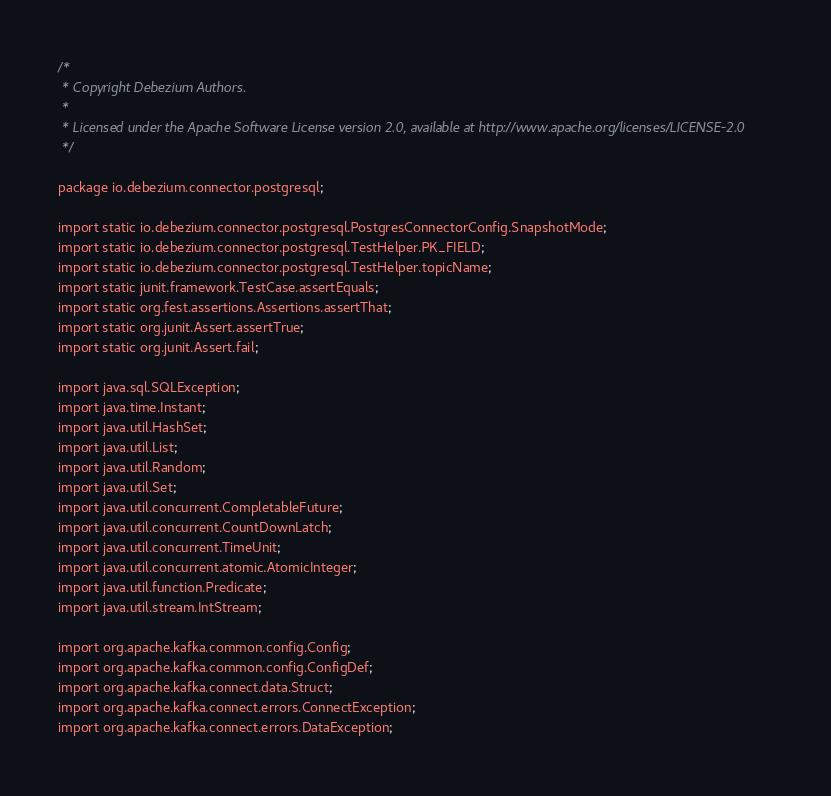<code> <loc_0><loc_0><loc_500><loc_500><_Java_>/*
 * Copyright Debezium Authors.
 *
 * Licensed under the Apache Software License version 2.0, available at http://www.apache.org/licenses/LICENSE-2.0
 */

package io.debezium.connector.postgresql;

import static io.debezium.connector.postgresql.PostgresConnectorConfig.SnapshotMode;
import static io.debezium.connector.postgresql.TestHelper.PK_FIELD;
import static io.debezium.connector.postgresql.TestHelper.topicName;
import static junit.framework.TestCase.assertEquals;
import static org.fest.assertions.Assertions.assertThat;
import static org.junit.Assert.assertTrue;
import static org.junit.Assert.fail;

import java.sql.SQLException;
import java.time.Instant;
import java.util.HashSet;
import java.util.List;
import java.util.Random;
import java.util.Set;
import java.util.concurrent.CompletableFuture;
import java.util.concurrent.CountDownLatch;
import java.util.concurrent.TimeUnit;
import java.util.concurrent.atomic.AtomicInteger;
import java.util.function.Predicate;
import java.util.stream.IntStream;

import org.apache.kafka.common.config.Config;
import org.apache.kafka.common.config.ConfigDef;
import org.apache.kafka.connect.data.Struct;
import org.apache.kafka.connect.errors.ConnectException;
import org.apache.kafka.connect.errors.DataException;</code> 